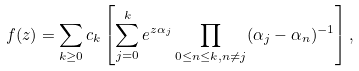Convert formula to latex. <formula><loc_0><loc_0><loc_500><loc_500>f ( z ) = \sum _ { k \geq 0 } c _ { k } \left [ \sum _ { j = 0 } ^ { k } e ^ { z \alpha _ { j } } \prod _ { 0 \leq n \leq k , n \not = j } ( \alpha _ { j } - \alpha _ { n } ) ^ { - 1 } \right ] ,</formula> 